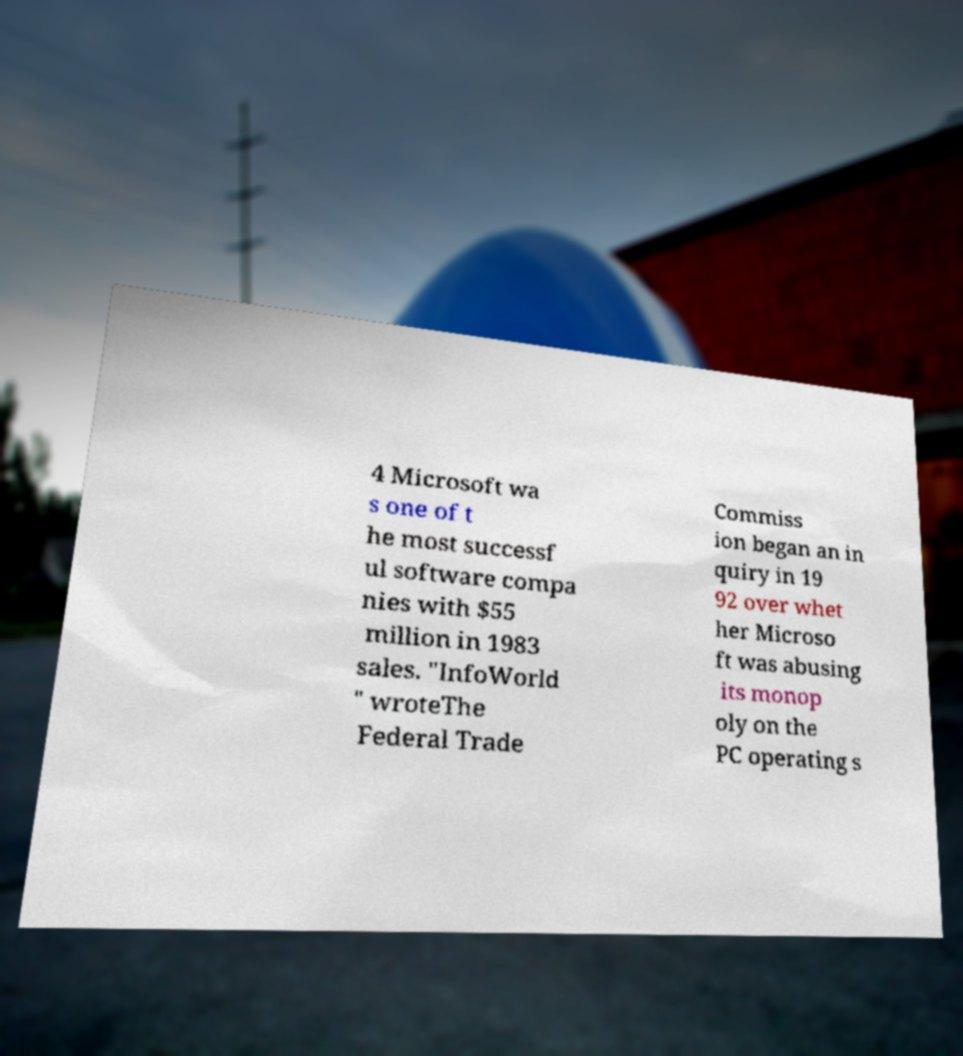For documentation purposes, I need the text within this image transcribed. Could you provide that? 4 Microsoft wa s one of t he most successf ul software compa nies with $55 million in 1983 sales. "InfoWorld " wroteThe Federal Trade Commiss ion began an in quiry in 19 92 over whet her Microso ft was abusing its monop oly on the PC operating s 